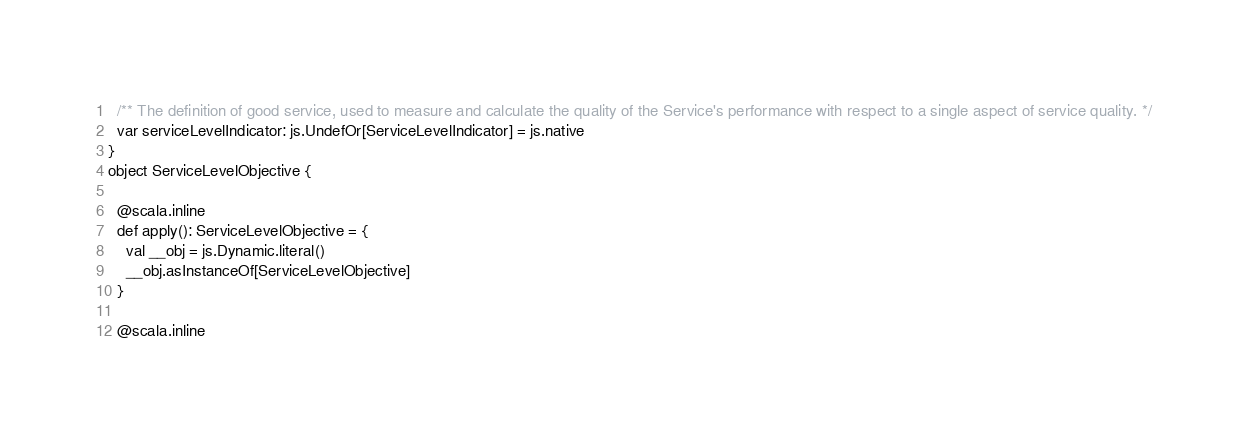Convert code to text. <code><loc_0><loc_0><loc_500><loc_500><_Scala_>  /** The definition of good service, used to measure and calculate the quality of the Service's performance with respect to a single aspect of service quality. */
  var serviceLevelIndicator: js.UndefOr[ServiceLevelIndicator] = js.native
}
object ServiceLevelObjective {
  
  @scala.inline
  def apply(): ServiceLevelObjective = {
    val __obj = js.Dynamic.literal()
    __obj.asInstanceOf[ServiceLevelObjective]
  }
  
  @scala.inline</code> 